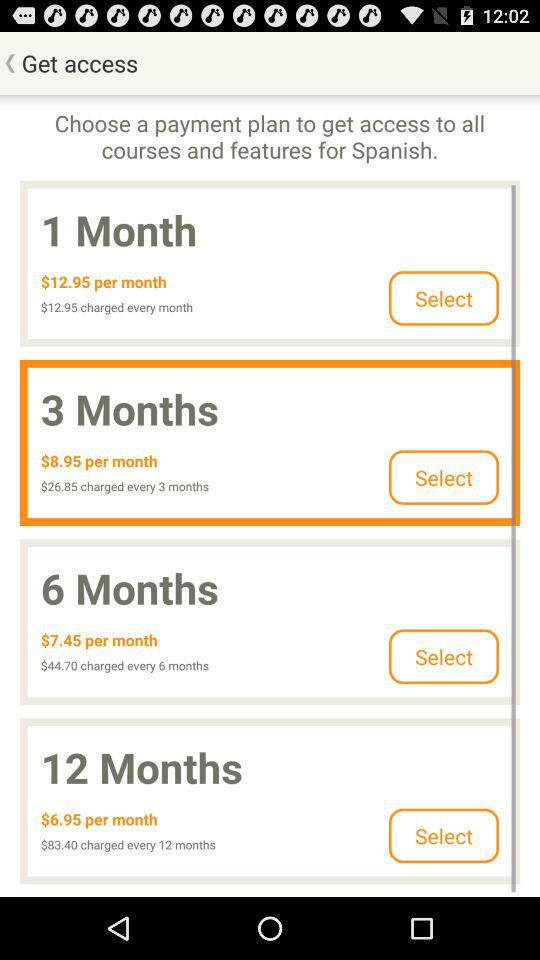Which payment plan is chosen? The chosen payment plan is "3 Months". 